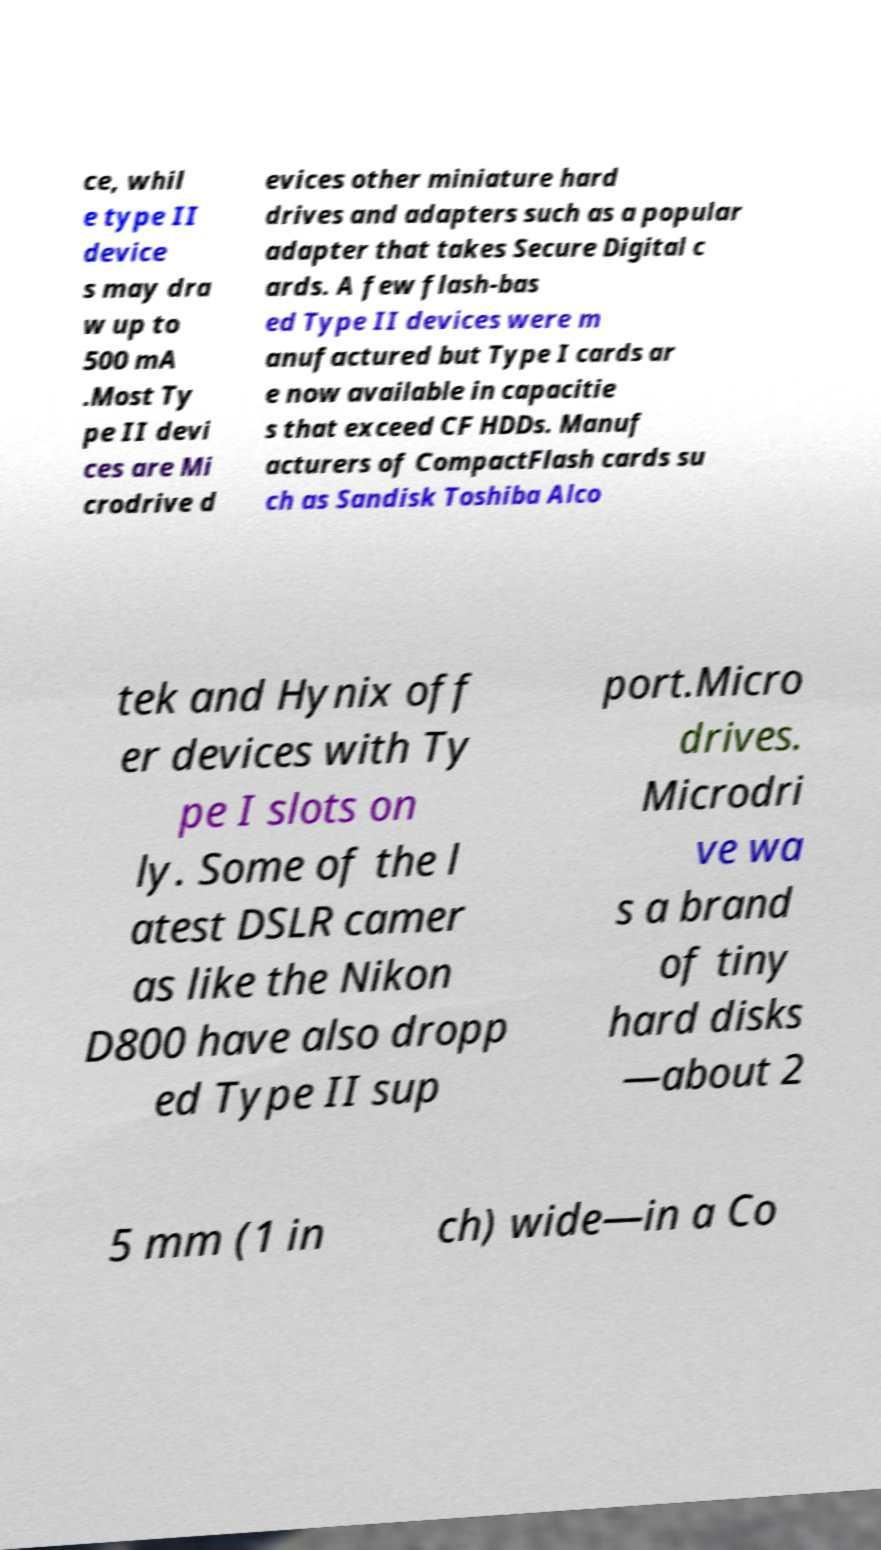Can you read and provide the text displayed in the image?This photo seems to have some interesting text. Can you extract and type it out for me? ce, whil e type II device s may dra w up to 500 mA .Most Ty pe II devi ces are Mi crodrive d evices other miniature hard drives and adapters such as a popular adapter that takes Secure Digital c ards. A few flash-bas ed Type II devices were m anufactured but Type I cards ar e now available in capacitie s that exceed CF HDDs. Manuf acturers of CompactFlash cards su ch as Sandisk Toshiba Alco tek and Hynix off er devices with Ty pe I slots on ly. Some of the l atest DSLR camer as like the Nikon D800 have also dropp ed Type II sup port.Micro drives. Microdri ve wa s a brand of tiny hard disks —about 2 5 mm (1 in ch) wide—in a Co 